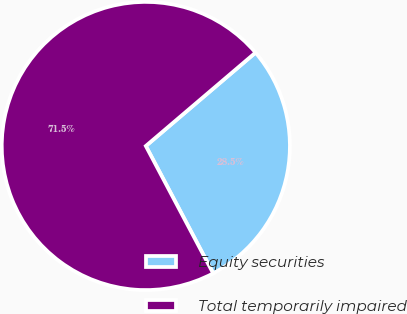Convert chart. <chart><loc_0><loc_0><loc_500><loc_500><pie_chart><fcel>Equity securities<fcel>Total temporarily impaired<nl><fcel>28.48%<fcel>71.52%<nl></chart> 